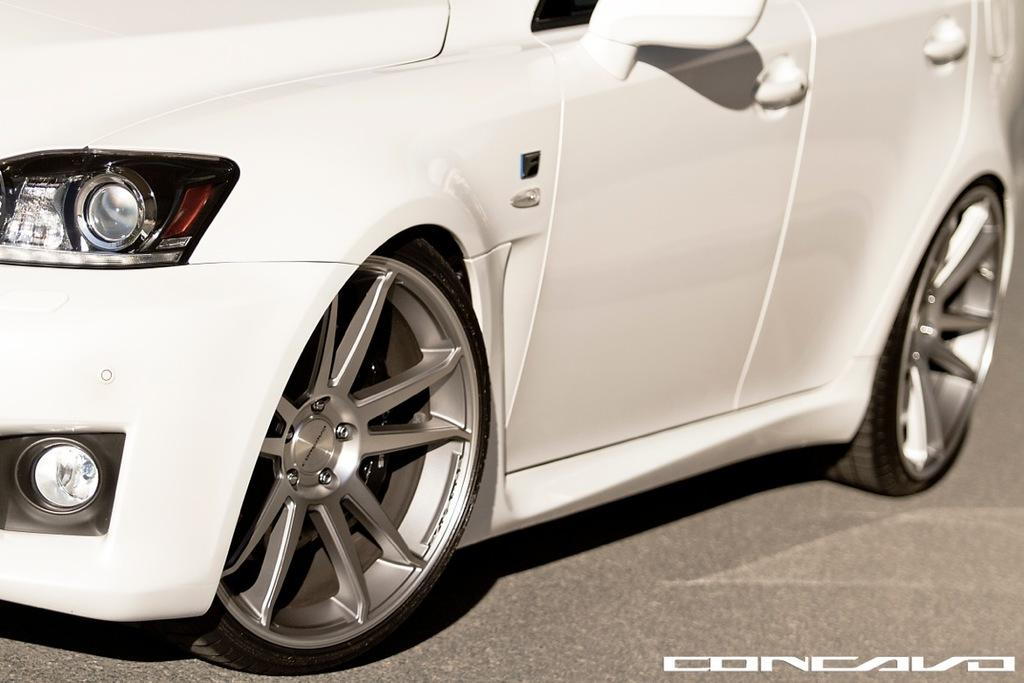What color is the car in the image? The car in the image is white. Can you describe any text present in the image? There is some text at the right bottom of the image. What type of pencil can be seen in the image? There is no pencil present in the image. What is the car's destination on its voyage in the image? The image does not depict a car on a voyage, nor does it provide information about the car's destination. 